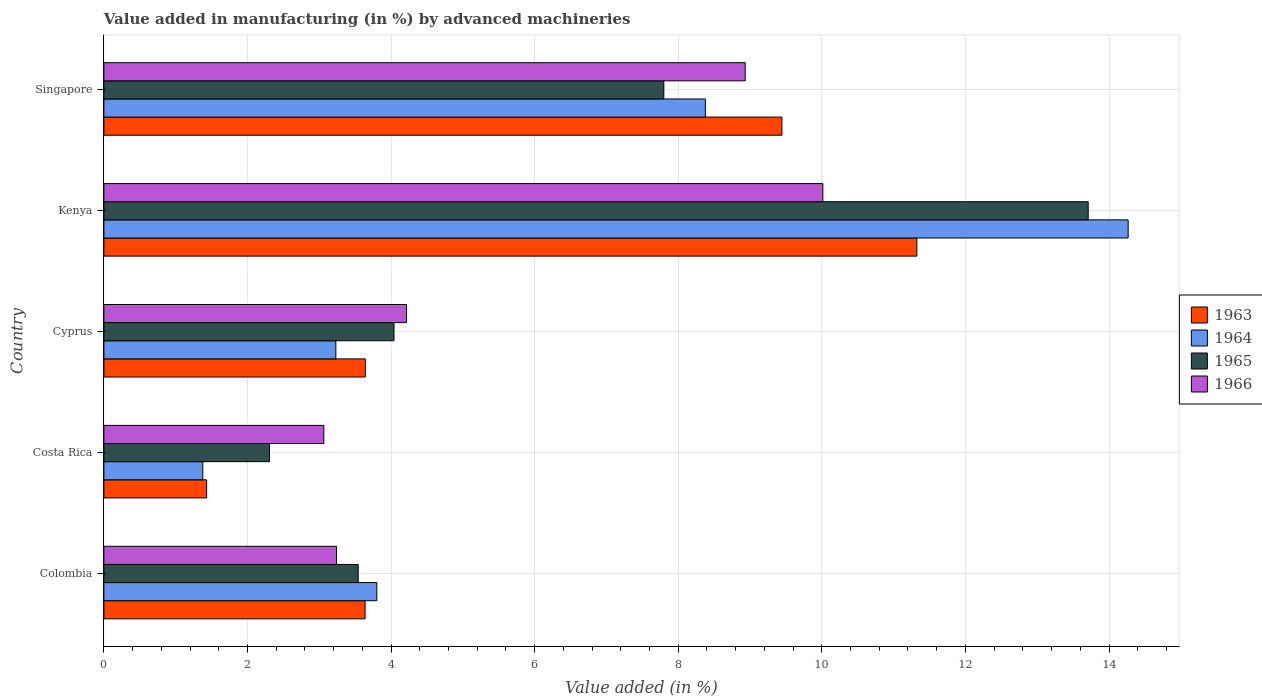How many different coloured bars are there?
Keep it short and to the point. 4. How many bars are there on the 5th tick from the bottom?
Provide a short and direct response. 4. What is the label of the 2nd group of bars from the top?
Provide a succinct answer. Kenya. What is the percentage of value added in manufacturing by advanced machineries in 1964 in Singapore?
Ensure brevity in your answer.  8.38. Across all countries, what is the maximum percentage of value added in manufacturing by advanced machineries in 1963?
Keep it short and to the point. 11.32. Across all countries, what is the minimum percentage of value added in manufacturing by advanced machineries in 1965?
Provide a succinct answer. 2.31. In which country was the percentage of value added in manufacturing by advanced machineries in 1966 maximum?
Give a very brief answer. Kenya. What is the total percentage of value added in manufacturing by advanced machineries in 1963 in the graph?
Provide a succinct answer. 29.48. What is the difference between the percentage of value added in manufacturing by advanced machineries in 1963 in Costa Rica and that in Cyprus?
Your answer should be very brief. -2.21. What is the difference between the percentage of value added in manufacturing by advanced machineries in 1965 in Cyprus and the percentage of value added in manufacturing by advanced machineries in 1963 in Costa Rica?
Ensure brevity in your answer.  2.61. What is the average percentage of value added in manufacturing by advanced machineries in 1963 per country?
Your response must be concise. 5.9. What is the difference between the percentage of value added in manufacturing by advanced machineries in 1965 and percentage of value added in manufacturing by advanced machineries in 1964 in Colombia?
Your answer should be very brief. -0.26. In how many countries, is the percentage of value added in manufacturing by advanced machineries in 1965 greater than 7.6 %?
Offer a terse response. 2. What is the ratio of the percentage of value added in manufacturing by advanced machineries in 1966 in Kenya to that in Singapore?
Offer a terse response. 1.12. Is the percentage of value added in manufacturing by advanced machineries in 1965 in Colombia less than that in Costa Rica?
Your response must be concise. No. Is the difference between the percentage of value added in manufacturing by advanced machineries in 1965 in Kenya and Singapore greater than the difference between the percentage of value added in manufacturing by advanced machineries in 1964 in Kenya and Singapore?
Give a very brief answer. Yes. What is the difference between the highest and the second highest percentage of value added in manufacturing by advanced machineries in 1965?
Provide a succinct answer. 5.91. What is the difference between the highest and the lowest percentage of value added in manufacturing by advanced machineries in 1965?
Provide a succinct answer. 11.4. In how many countries, is the percentage of value added in manufacturing by advanced machineries in 1966 greater than the average percentage of value added in manufacturing by advanced machineries in 1966 taken over all countries?
Keep it short and to the point. 2. What does the 3rd bar from the top in Colombia represents?
Offer a terse response. 1964. What does the 4th bar from the bottom in Singapore represents?
Ensure brevity in your answer.  1966. Is it the case that in every country, the sum of the percentage of value added in manufacturing by advanced machineries in 1963 and percentage of value added in manufacturing by advanced machineries in 1966 is greater than the percentage of value added in manufacturing by advanced machineries in 1965?
Provide a short and direct response. Yes. How many bars are there?
Keep it short and to the point. 20. How many countries are there in the graph?
Your answer should be compact. 5. Are the values on the major ticks of X-axis written in scientific E-notation?
Keep it short and to the point. No. Does the graph contain grids?
Your answer should be compact. Yes. Where does the legend appear in the graph?
Keep it short and to the point. Center right. How are the legend labels stacked?
Offer a very short reply. Vertical. What is the title of the graph?
Your response must be concise. Value added in manufacturing (in %) by advanced machineries. What is the label or title of the X-axis?
Provide a succinct answer. Value added (in %). What is the label or title of the Y-axis?
Offer a terse response. Country. What is the Value added (in %) of 1963 in Colombia?
Offer a very short reply. 3.64. What is the Value added (in %) in 1964 in Colombia?
Your response must be concise. 3.8. What is the Value added (in %) in 1965 in Colombia?
Provide a succinct answer. 3.54. What is the Value added (in %) of 1966 in Colombia?
Provide a short and direct response. 3.24. What is the Value added (in %) in 1963 in Costa Rica?
Provide a short and direct response. 1.43. What is the Value added (in %) of 1964 in Costa Rica?
Offer a terse response. 1.38. What is the Value added (in %) of 1965 in Costa Rica?
Provide a succinct answer. 2.31. What is the Value added (in %) of 1966 in Costa Rica?
Your answer should be compact. 3.06. What is the Value added (in %) in 1963 in Cyprus?
Offer a terse response. 3.64. What is the Value added (in %) of 1964 in Cyprus?
Offer a terse response. 3.23. What is the Value added (in %) in 1965 in Cyprus?
Ensure brevity in your answer.  4.04. What is the Value added (in %) of 1966 in Cyprus?
Provide a short and direct response. 4.22. What is the Value added (in %) in 1963 in Kenya?
Your response must be concise. 11.32. What is the Value added (in %) of 1964 in Kenya?
Ensure brevity in your answer.  14.27. What is the Value added (in %) of 1965 in Kenya?
Ensure brevity in your answer.  13.71. What is the Value added (in %) of 1966 in Kenya?
Your answer should be compact. 10.01. What is the Value added (in %) of 1963 in Singapore?
Your answer should be compact. 9.44. What is the Value added (in %) of 1964 in Singapore?
Offer a terse response. 8.38. What is the Value added (in %) in 1965 in Singapore?
Ensure brevity in your answer.  7.8. What is the Value added (in %) in 1966 in Singapore?
Keep it short and to the point. 8.93. Across all countries, what is the maximum Value added (in %) in 1963?
Keep it short and to the point. 11.32. Across all countries, what is the maximum Value added (in %) in 1964?
Offer a very short reply. 14.27. Across all countries, what is the maximum Value added (in %) of 1965?
Your response must be concise. 13.71. Across all countries, what is the maximum Value added (in %) in 1966?
Offer a terse response. 10.01. Across all countries, what is the minimum Value added (in %) in 1963?
Your answer should be compact. 1.43. Across all countries, what is the minimum Value added (in %) in 1964?
Keep it short and to the point. 1.38. Across all countries, what is the minimum Value added (in %) in 1965?
Your response must be concise. 2.31. Across all countries, what is the minimum Value added (in %) of 1966?
Provide a short and direct response. 3.06. What is the total Value added (in %) in 1963 in the graph?
Provide a succinct answer. 29.48. What is the total Value added (in %) of 1964 in the graph?
Provide a succinct answer. 31.05. What is the total Value added (in %) of 1965 in the graph?
Provide a succinct answer. 31.4. What is the total Value added (in %) in 1966 in the graph?
Your answer should be very brief. 29.47. What is the difference between the Value added (in %) in 1963 in Colombia and that in Costa Rica?
Your answer should be compact. 2.21. What is the difference between the Value added (in %) in 1964 in Colombia and that in Costa Rica?
Offer a very short reply. 2.42. What is the difference between the Value added (in %) in 1965 in Colombia and that in Costa Rica?
Provide a succinct answer. 1.24. What is the difference between the Value added (in %) in 1966 in Colombia and that in Costa Rica?
Make the answer very short. 0.18. What is the difference between the Value added (in %) in 1963 in Colombia and that in Cyprus?
Give a very brief answer. -0. What is the difference between the Value added (in %) of 1964 in Colombia and that in Cyprus?
Your response must be concise. 0.57. What is the difference between the Value added (in %) in 1965 in Colombia and that in Cyprus?
Your response must be concise. -0.5. What is the difference between the Value added (in %) in 1966 in Colombia and that in Cyprus?
Give a very brief answer. -0.97. What is the difference between the Value added (in %) of 1963 in Colombia and that in Kenya?
Ensure brevity in your answer.  -7.69. What is the difference between the Value added (in %) in 1964 in Colombia and that in Kenya?
Offer a terse response. -10.47. What is the difference between the Value added (in %) of 1965 in Colombia and that in Kenya?
Provide a succinct answer. -10.17. What is the difference between the Value added (in %) in 1966 in Colombia and that in Kenya?
Give a very brief answer. -6.77. What is the difference between the Value added (in %) of 1963 in Colombia and that in Singapore?
Provide a succinct answer. -5.81. What is the difference between the Value added (in %) in 1964 in Colombia and that in Singapore?
Provide a short and direct response. -4.58. What is the difference between the Value added (in %) of 1965 in Colombia and that in Singapore?
Provide a short and direct response. -4.26. What is the difference between the Value added (in %) in 1966 in Colombia and that in Singapore?
Make the answer very short. -5.69. What is the difference between the Value added (in %) of 1963 in Costa Rica and that in Cyprus?
Keep it short and to the point. -2.21. What is the difference between the Value added (in %) of 1964 in Costa Rica and that in Cyprus?
Your answer should be compact. -1.85. What is the difference between the Value added (in %) of 1965 in Costa Rica and that in Cyprus?
Your response must be concise. -1.73. What is the difference between the Value added (in %) in 1966 in Costa Rica and that in Cyprus?
Your response must be concise. -1.15. What is the difference between the Value added (in %) of 1963 in Costa Rica and that in Kenya?
Keep it short and to the point. -9.89. What is the difference between the Value added (in %) of 1964 in Costa Rica and that in Kenya?
Your response must be concise. -12.89. What is the difference between the Value added (in %) in 1965 in Costa Rica and that in Kenya?
Give a very brief answer. -11.4. What is the difference between the Value added (in %) in 1966 in Costa Rica and that in Kenya?
Ensure brevity in your answer.  -6.95. What is the difference between the Value added (in %) of 1963 in Costa Rica and that in Singapore?
Keep it short and to the point. -8.01. What is the difference between the Value added (in %) in 1964 in Costa Rica and that in Singapore?
Your answer should be very brief. -7. What is the difference between the Value added (in %) of 1965 in Costa Rica and that in Singapore?
Provide a succinct answer. -5.49. What is the difference between the Value added (in %) in 1966 in Costa Rica and that in Singapore?
Keep it short and to the point. -5.87. What is the difference between the Value added (in %) in 1963 in Cyprus and that in Kenya?
Give a very brief answer. -7.68. What is the difference between the Value added (in %) of 1964 in Cyprus and that in Kenya?
Make the answer very short. -11.04. What is the difference between the Value added (in %) in 1965 in Cyprus and that in Kenya?
Your answer should be compact. -9.67. What is the difference between the Value added (in %) in 1966 in Cyprus and that in Kenya?
Make the answer very short. -5.8. What is the difference between the Value added (in %) of 1963 in Cyprus and that in Singapore?
Your answer should be compact. -5.8. What is the difference between the Value added (in %) of 1964 in Cyprus and that in Singapore?
Keep it short and to the point. -5.15. What is the difference between the Value added (in %) in 1965 in Cyprus and that in Singapore?
Provide a short and direct response. -3.76. What is the difference between the Value added (in %) of 1966 in Cyprus and that in Singapore?
Keep it short and to the point. -4.72. What is the difference between the Value added (in %) of 1963 in Kenya and that in Singapore?
Make the answer very short. 1.88. What is the difference between the Value added (in %) in 1964 in Kenya and that in Singapore?
Keep it short and to the point. 5.89. What is the difference between the Value added (in %) in 1965 in Kenya and that in Singapore?
Provide a succinct answer. 5.91. What is the difference between the Value added (in %) of 1966 in Kenya and that in Singapore?
Provide a succinct answer. 1.08. What is the difference between the Value added (in %) of 1963 in Colombia and the Value added (in %) of 1964 in Costa Rica?
Keep it short and to the point. 2.26. What is the difference between the Value added (in %) of 1963 in Colombia and the Value added (in %) of 1965 in Costa Rica?
Offer a very short reply. 1.33. What is the difference between the Value added (in %) in 1963 in Colombia and the Value added (in %) in 1966 in Costa Rica?
Give a very brief answer. 0.57. What is the difference between the Value added (in %) in 1964 in Colombia and the Value added (in %) in 1965 in Costa Rica?
Ensure brevity in your answer.  1.49. What is the difference between the Value added (in %) in 1964 in Colombia and the Value added (in %) in 1966 in Costa Rica?
Your answer should be compact. 0.74. What is the difference between the Value added (in %) in 1965 in Colombia and the Value added (in %) in 1966 in Costa Rica?
Make the answer very short. 0.48. What is the difference between the Value added (in %) of 1963 in Colombia and the Value added (in %) of 1964 in Cyprus?
Your answer should be very brief. 0.41. What is the difference between the Value added (in %) in 1963 in Colombia and the Value added (in %) in 1965 in Cyprus?
Offer a terse response. -0.4. What is the difference between the Value added (in %) of 1963 in Colombia and the Value added (in %) of 1966 in Cyprus?
Provide a short and direct response. -0.58. What is the difference between the Value added (in %) of 1964 in Colombia and the Value added (in %) of 1965 in Cyprus?
Provide a short and direct response. -0.24. What is the difference between the Value added (in %) of 1964 in Colombia and the Value added (in %) of 1966 in Cyprus?
Keep it short and to the point. -0.41. What is the difference between the Value added (in %) in 1965 in Colombia and the Value added (in %) in 1966 in Cyprus?
Make the answer very short. -0.67. What is the difference between the Value added (in %) in 1963 in Colombia and the Value added (in %) in 1964 in Kenya?
Give a very brief answer. -10.63. What is the difference between the Value added (in %) of 1963 in Colombia and the Value added (in %) of 1965 in Kenya?
Your answer should be compact. -10.07. What is the difference between the Value added (in %) in 1963 in Colombia and the Value added (in %) in 1966 in Kenya?
Give a very brief answer. -6.38. What is the difference between the Value added (in %) of 1964 in Colombia and the Value added (in %) of 1965 in Kenya?
Offer a very short reply. -9.91. What is the difference between the Value added (in %) of 1964 in Colombia and the Value added (in %) of 1966 in Kenya?
Provide a succinct answer. -6.21. What is the difference between the Value added (in %) of 1965 in Colombia and the Value added (in %) of 1966 in Kenya?
Give a very brief answer. -6.47. What is the difference between the Value added (in %) in 1963 in Colombia and the Value added (in %) in 1964 in Singapore?
Offer a very short reply. -4.74. What is the difference between the Value added (in %) in 1963 in Colombia and the Value added (in %) in 1965 in Singapore?
Make the answer very short. -4.16. What is the difference between the Value added (in %) of 1963 in Colombia and the Value added (in %) of 1966 in Singapore?
Ensure brevity in your answer.  -5.29. What is the difference between the Value added (in %) of 1964 in Colombia and the Value added (in %) of 1965 in Singapore?
Offer a terse response. -4. What is the difference between the Value added (in %) in 1964 in Colombia and the Value added (in %) in 1966 in Singapore?
Your response must be concise. -5.13. What is the difference between the Value added (in %) of 1965 in Colombia and the Value added (in %) of 1966 in Singapore?
Offer a very short reply. -5.39. What is the difference between the Value added (in %) in 1963 in Costa Rica and the Value added (in %) in 1964 in Cyprus?
Your answer should be very brief. -1.8. What is the difference between the Value added (in %) of 1963 in Costa Rica and the Value added (in %) of 1965 in Cyprus?
Offer a very short reply. -2.61. What is the difference between the Value added (in %) in 1963 in Costa Rica and the Value added (in %) in 1966 in Cyprus?
Your response must be concise. -2.78. What is the difference between the Value added (in %) of 1964 in Costa Rica and the Value added (in %) of 1965 in Cyprus?
Keep it short and to the point. -2.66. What is the difference between the Value added (in %) of 1964 in Costa Rica and the Value added (in %) of 1966 in Cyprus?
Give a very brief answer. -2.84. What is the difference between the Value added (in %) in 1965 in Costa Rica and the Value added (in %) in 1966 in Cyprus?
Your answer should be compact. -1.91. What is the difference between the Value added (in %) in 1963 in Costa Rica and the Value added (in %) in 1964 in Kenya?
Your response must be concise. -12.84. What is the difference between the Value added (in %) in 1963 in Costa Rica and the Value added (in %) in 1965 in Kenya?
Your answer should be very brief. -12.28. What is the difference between the Value added (in %) in 1963 in Costa Rica and the Value added (in %) in 1966 in Kenya?
Provide a succinct answer. -8.58. What is the difference between the Value added (in %) in 1964 in Costa Rica and the Value added (in %) in 1965 in Kenya?
Give a very brief answer. -12.33. What is the difference between the Value added (in %) of 1964 in Costa Rica and the Value added (in %) of 1966 in Kenya?
Your answer should be very brief. -8.64. What is the difference between the Value added (in %) of 1965 in Costa Rica and the Value added (in %) of 1966 in Kenya?
Your response must be concise. -7.71. What is the difference between the Value added (in %) in 1963 in Costa Rica and the Value added (in %) in 1964 in Singapore?
Your answer should be very brief. -6.95. What is the difference between the Value added (in %) in 1963 in Costa Rica and the Value added (in %) in 1965 in Singapore?
Provide a succinct answer. -6.37. What is the difference between the Value added (in %) of 1963 in Costa Rica and the Value added (in %) of 1966 in Singapore?
Your response must be concise. -7.5. What is the difference between the Value added (in %) in 1964 in Costa Rica and the Value added (in %) in 1965 in Singapore?
Offer a very short reply. -6.42. What is the difference between the Value added (in %) in 1964 in Costa Rica and the Value added (in %) in 1966 in Singapore?
Keep it short and to the point. -7.55. What is the difference between the Value added (in %) in 1965 in Costa Rica and the Value added (in %) in 1966 in Singapore?
Offer a very short reply. -6.63. What is the difference between the Value added (in %) in 1963 in Cyprus and the Value added (in %) in 1964 in Kenya?
Provide a succinct answer. -10.63. What is the difference between the Value added (in %) of 1963 in Cyprus and the Value added (in %) of 1965 in Kenya?
Offer a terse response. -10.07. What is the difference between the Value added (in %) of 1963 in Cyprus and the Value added (in %) of 1966 in Kenya?
Your answer should be compact. -6.37. What is the difference between the Value added (in %) in 1964 in Cyprus and the Value added (in %) in 1965 in Kenya?
Keep it short and to the point. -10.48. What is the difference between the Value added (in %) in 1964 in Cyprus and the Value added (in %) in 1966 in Kenya?
Keep it short and to the point. -6.78. What is the difference between the Value added (in %) of 1965 in Cyprus and the Value added (in %) of 1966 in Kenya?
Keep it short and to the point. -5.97. What is the difference between the Value added (in %) of 1963 in Cyprus and the Value added (in %) of 1964 in Singapore?
Your answer should be compact. -4.74. What is the difference between the Value added (in %) in 1963 in Cyprus and the Value added (in %) in 1965 in Singapore?
Give a very brief answer. -4.16. What is the difference between the Value added (in %) in 1963 in Cyprus and the Value added (in %) in 1966 in Singapore?
Your response must be concise. -5.29. What is the difference between the Value added (in %) of 1964 in Cyprus and the Value added (in %) of 1965 in Singapore?
Provide a short and direct response. -4.57. What is the difference between the Value added (in %) of 1964 in Cyprus and the Value added (in %) of 1966 in Singapore?
Provide a succinct answer. -5.7. What is the difference between the Value added (in %) of 1965 in Cyprus and the Value added (in %) of 1966 in Singapore?
Offer a very short reply. -4.89. What is the difference between the Value added (in %) in 1963 in Kenya and the Value added (in %) in 1964 in Singapore?
Make the answer very short. 2.95. What is the difference between the Value added (in %) in 1963 in Kenya and the Value added (in %) in 1965 in Singapore?
Your answer should be compact. 3.52. What is the difference between the Value added (in %) in 1963 in Kenya and the Value added (in %) in 1966 in Singapore?
Ensure brevity in your answer.  2.39. What is the difference between the Value added (in %) of 1964 in Kenya and the Value added (in %) of 1965 in Singapore?
Offer a very short reply. 6.47. What is the difference between the Value added (in %) of 1964 in Kenya and the Value added (in %) of 1966 in Singapore?
Keep it short and to the point. 5.33. What is the difference between the Value added (in %) in 1965 in Kenya and the Value added (in %) in 1966 in Singapore?
Offer a terse response. 4.78. What is the average Value added (in %) in 1963 per country?
Provide a succinct answer. 5.9. What is the average Value added (in %) of 1964 per country?
Keep it short and to the point. 6.21. What is the average Value added (in %) in 1965 per country?
Make the answer very short. 6.28. What is the average Value added (in %) in 1966 per country?
Your answer should be compact. 5.89. What is the difference between the Value added (in %) of 1963 and Value added (in %) of 1964 in Colombia?
Offer a very short reply. -0.16. What is the difference between the Value added (in %) in 1963 and Value added (in %) in 1965 in Colombia?
Give a very brief answer. 0.1. What is the difference between the Value added (in %) in 1963 and Value added (in %) in 1966 in Colombia?
Provide a short and direct response. 0.4. What is the difference between the Value added (in %) in 1964 and Value added (in %) in 1965 in Colombia?
Provide a short and direct response. 0.26. What is the difference between the Value added (in %) of 1964 and Value added (in %) of 1966 in Colombia?
Ensure brevity in your answer.  0.56. What is the difference between the Value added (in %) of 1965 and Value added (in %) of 1966 in Colombia?
Give a very brief answer. 0.3. What is the difference between the Value added (in %) of 1963 and Value added (in %) of 1964 in Costa Rica?
Offer a terse response. 0.05. What is the difference between the Value added (in %) in 1963 and Value added (in %) in 1965 in Costa Rica?
Give a very brief answer. -0.88. What is the difference between the Value added (in %) of 1963 and Value added (in %) of 1966 in Costa Rica?
Provide a succinct answer. -1.63. What is the difference between the Value added (in %) in 1964 and Value added (in %) in 1965 in Costa Rica?
Offer a very short reply. -0.93. What is the difference between the Value added (in %) in 1964 and Value added (in %) in 1966 in Costa Rica?
Offer a terse response. -1.69. What is the difference between the Value added (in %) in 1965 and Value added (in %) in 1966 in Costa Rica?
Your answer should be very brief. -0.76. What is the difference between the Value added (in %) in 1963 and Value added (in %) in 1964 in Cyprus?
Your answer should be compact. 0.41. What is the difference between the Value added (in %) in 1963 and Value added (in %) in 1965 in Cyprus?
Provide a succinct answer. -0.4. What is the difference between the Value added (in %) in 1963 and Value added (in %) in 1966 in Cyprus?
Provide a short and direct response. -0.57. What is the difference between the Value added (in %) of 1964 and Value added (in %) of 1965 in Cyprus?
Give a very brief answer. -0.81. What is the difference between the Value added (in %) of 1964 and Value added (in %) of 1966 in Cyprus?
Offer a terse response. -0.98. What is the difference between the Value added (in %) of 1965 and Value added (in %) of 1966 in Cyprus?
Provide a short and direct response. -0.17. What is the difference between the Value added (in %) of 1963 and Value added (in %) of 1964 in Kenya?
Make the answer very short. -2.94. What is the difference between the Value added (in %) in 1963 and Value added (in %) in 1965 in Kenya?
Your answer should be very brief. -2.39. What is the difference between the Value added (in %) of 1963 and Value added (in %) of 1966 in Kenya?
Offer a very short reply. 1.31. What is the difference between the Value added (in %) in 1964 and Value added (in %) in 1965 in Kenya?
Your answer should be very brief. 0.56. What is the difference between the Value added (in %) of 1964 and Value added (in %) of 1966 in Kenya?
Provide a short and direct response. 4.25. What is the difference between the Value added (in %) of 1965 and Value added (in %) of 1966 in Kenya?
Your answer should be very brief. 3.7. What is the difference between the Value added (in %) of 1963 and Value added (in %) of 1964 in Singapore?
Make the answer very short. 1.07. What is the difference between the Value added (in %) in 1963 and Value added (in %) in 1965 in Singapore?
Your response must be concise. 1.64. What is the difference between the Value added (in %) of 1963 and Value added (in %) of 1966 in Singapore?
Make the answer very short. 0.51. What is the difference between the Value added (in %) of 1964 and Value added (in %) of 1965 in Singapore?
Keep it short and to the point. 0.58. What is the difference between the Value added (in %) in 1964 and Value added (in %) in 1966 in Singapore?
Ensure brevity in your answer.  -0.55. What is the difference between the Value added (in %) of 1965 and Value added (in %) of 1966 in Singapore?
Your answer should be compact. -1.13. What is the ratio of the Value added (in %) in 1963 in Colombia to that in Costa Rica?
Provide a succinct answer. 2.54. What is the ratio of the Value added (in %) in 1964 in Colombia to that in Costa Rica?
Give a very brief answer. 2.76. What is the ratio of the Value added (in %) in 1965 in Colombia to that in Costa Rica?
Provide a short and direct response. 1.54. What is the ratio of the Value added (in %) of 1966 in Colombia to that in Costa Rica?
Keep it short and to the point. 1.06. What is the ratio of the Value added (in %) in 1964 in Colombia to that in Cyprus?
Your answer should be very brief. 1.18. What is the ratio of the Value added (in %) in 1965 in Colombia to that in Cyprus?
Your answer should be compact. 0.88. What is the ratio of the Value added (in %) in 1966 in Colombia to that in Cyprus?
Your answer should be very brief. 0.77. What is the ratio of the Value added (in %) of 1963 in Colombia to that in Kenya?
Give a very brief answer. 0.32. What is the ratio of the Value added (in %) of 1964 in Colombia to that in Kenya?
Provide a short and direct response. 0.27. What is the ratio of the Value added (in %) in 1965 in Colombia to that in Kenya?
Make the answer very short. 0.26. What is the ratio of the Value added (in %) of 1966 in Colombia to that in Kenya?
Make the answer very short. 0.32. What is the ratio of the Value added (in %) of 1963 in Colombia to that in Singapore?
Your answer should be very brief. 0.39. What is the ratio of the Value added (in %) in 1964 in Colombia to that in Singapore?
Ensure brevity in your answer.  0.45. What is the ratio of the Value added (in %) in 1965 in Colombia to that in Singapore?
Offer a terse response. 0.45. What is the ratio of the Value added (in %) in 1966 in Colombia to that in Singapore?
Offer a terse response. 0.36. What is the ratio of the Value added (in %) of 1963 in Costa Rica to that in Cyprus?
Ensure brevity in your answer.  0.39. What is the ratio of the Value added (in %) of 1964 in Costa Rica to that in Cyprus?
Provide a succinct answer. 0.43. What is the ratio of the Value added (in %) of 1965 in Costa Rica to that in Cyprus?
Give a very brief answer. 0.57. What is the ratio of the Value added (in %) of 1966 in Costa Rica to that in Cyprus?
Give a very brief answer. 0.73. What is the ratio of the Value added (in %) of 1963 in Costa Rica to that in Kenya?
Your answer should be very brief. 0.13. What is the ratio of the Value added (in %) in 1964 in Costa Rica to that in Kenya?
Offer a terse response. 0.1. What is the ratio of the Value added (in %) in 1965 in Costa Rica to that in Kenya?
Give a very brief answer. 0.17. What is the ratio of the Value added (in %) of 1966 in Costa Rica to that in Kenya?
Give a very brief answer. 0.31. What is the ratio of the Value added (in %) of 1963 in Costa Rica to that in Singapore?
Give a very brief answer. 0.15. What is the ratio of the Value added (in %) in 1964 in Costa Rica to that in Singapore?
Offer a very short reply. 0.16. What is the ratio of the Value added (in %) of 1965 in Costa Rica to that in Singapore?
Ensure brevity in your answer.  0.3. What is the ratio of the Value added (in %) in 1966 in Costa Rica to that in Singapore?
Keep it short and to the point. 0.34. What is the ratio of the Value added (in %) of 1963 in Cyprus to that in Kenya?
Your response must be concise. 0.32. What is the ratio of the Value added (in %) of 1964 in Cyprus to that in Kenya?
Make the answer very short. 0.23. What is the ratio of the Value added (in %) in 1965 in Cyprus to that in Kenya?
Offer a very short reply. 0.29. What is the ratio of the Value added (in %) in 1966 in Cyprus to that in Kenya?
Provide a succinct answer. 0.42. What is the ratio of the Value added (in %) in 1963 in Cyprus to that in Singapore?
Make the answer very short. 0.39. What is the ratio of the Value added (in %) of 1964 in Cyprus to that in Singapore?
Offer a terse response. 0.39. What is the ratio of the Value added (in %) of 1965 in Cyprus to that in Singapore?
Your response must be concise. 0.52. What is the ratio of the Value added (in %) in 1966 in Cyprus to that in Singapore?
Keep it short and to the point. 0.47. What is the ratio of the Value added (in %) in 1963 in Kenya to that in Singapore?
Offer a terse response. 1.2. What is the ratio of the Value added (in %) in 1964 in Kenya to that in Singapore?
Make the answer very short. 1.7. What is the ratio of the Value added (in %) of 1965 in Kenya to that in Singapore?
Ensure brevity in your answer.  1.76. What is the ratio of the Value added (in %) in 1966 in Kenya to that in Singapore?
Give a very brief answer. 1.12. What is the difference between the highest and the second highest Value added (in %) of 1963?
Offer a very short reply. 1.88. What is the difference between the highest and the second highest Value added (in %) of 1964?
Your response must be concise. 5.89. What is the difference between the highest and the second highest Value added (in %) of 1965?
Offer a very short reply. 5.91. What is the difference between the highest and the second highest Value added (in %) in 1966?
Offer a terse response. 1.08. What is the difference between the highest and the lowest Value added (in %) in 1963?
Provide a short and direct response. 9.89. What is the difference between the highest and the lowest Value added (in %) in 1964?
Your response must be concise. 12.89. What is the difference between the highest and the lowest Value added (in %) in 1965?
Ensure brevity in your answer.  11.4. What is the difference between the highest and the lowest Value added (in %) in 1966?
Make the answer very short. 6.95. 